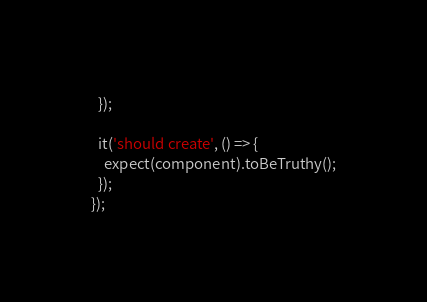Convert code to text. <code><loc_0><loc_0><loc_500><loc_500><_TypeScript_>  });

  it('should create', () => {
    expect(component).toBeTruthy();
  });
});
</code> 